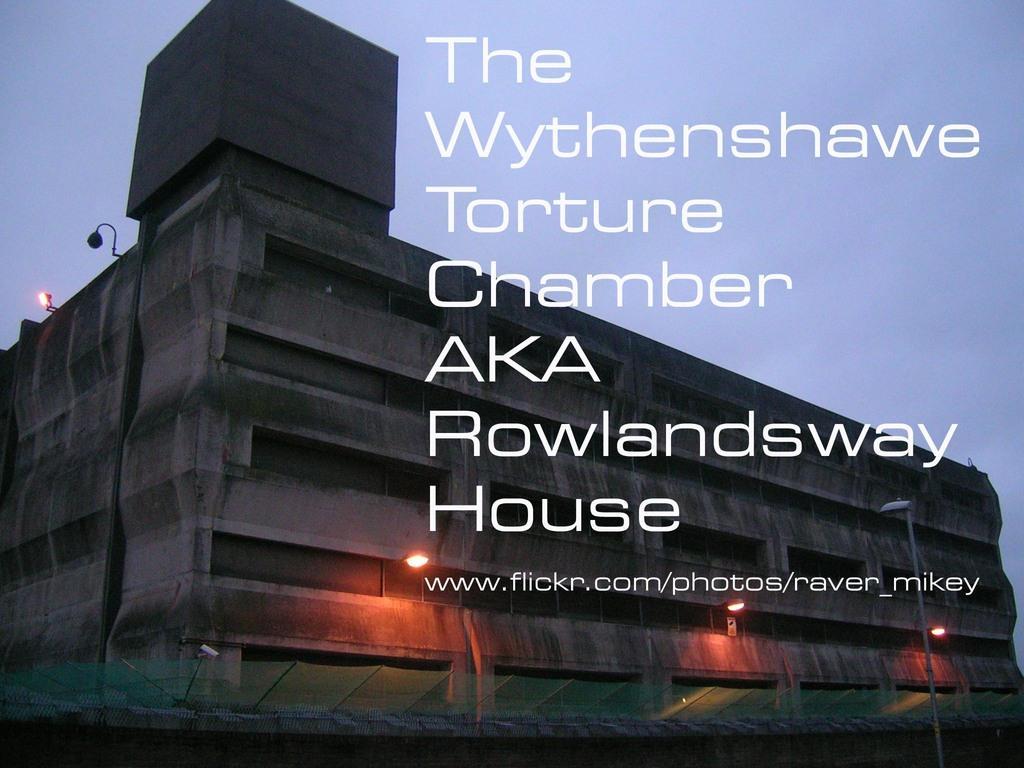Could you give a brief overview of what you see in this image? In the image we can see there is a poster and there is a concrete building. There are street light poles on the ground and there is a clear sky. 